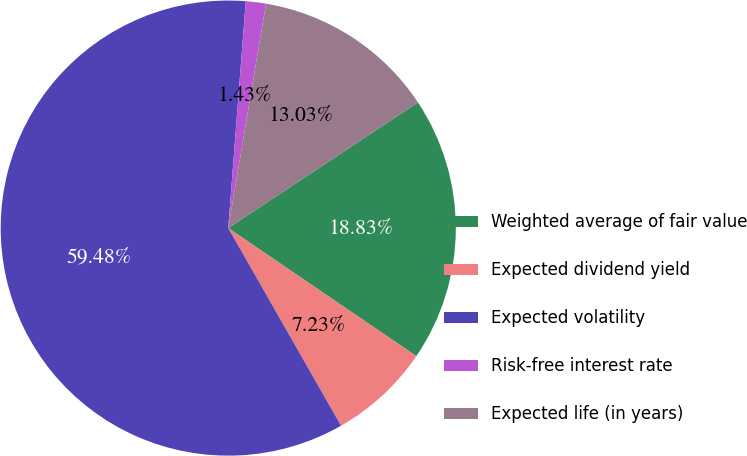<chart> <loc_0><loc_0><loc_500><loc_500><pie_chart><fcel>Weighted average of fair value<fcel>Expected dividend yield<fcel>Expected volatility<fcel>Risk-free interest rate<fcel>Expected life (in years)<nl><fcel>18.83%<fcel>7.23%<fcel>59.48%<fcel>1.43%<fcel>13.03%<nl></chart> 